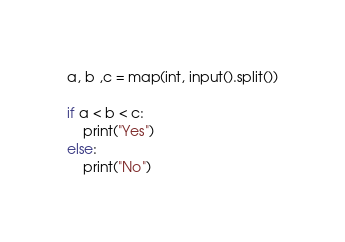Convert code to text. <code><loc_0><loc_0><loc_500><loc_500><_Python_>a, b ,c = map(int, input().split())

if a < b < c:
	print("Yes")
else:
	print("No")
</code> 